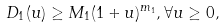Convert formula to latex. <formula><loc_0><loc_0><loc_500><loc_500>D _ { 1 } ( u ) \geq M _ { 1 } ( 1 + u ) ^ { m _ { 1 } } , \forall u \geq 0 ,</formula> 